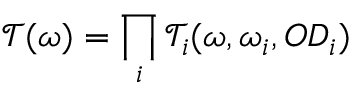Convert formula to latex. <formula><loc_0><loc_0><loc_500><loc_500>\mathcal { T } ( \omega ) = \prod _ { i } \mathcal { T } _ { i } ( \omega , \omega _ { i } , O D _ { i } )</formula> 